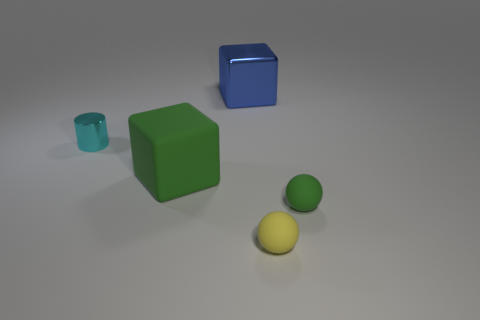Add 4 yellow rubber things. How many objects exist? 9 Subtract all spheres. How many objects are left? 3 Subtract 1 spheres. How many spheres are left? 1 Subtract all blue blocks. Subtract all gray spheres. How many blocks are left? 1 Subtract all brown blocks. How many yellow spheres are left? 1 Subtract all cyan metallic cylinders. Subtract all tiny objects. How many objects are left? 1 Add 2 large blue shiny cubes. How many large blue shiny cubes are left? 3 Add 3 small spheres. How many small spheres exist? 5 Subtract 0 green cylinders. How many objects are left? 5 